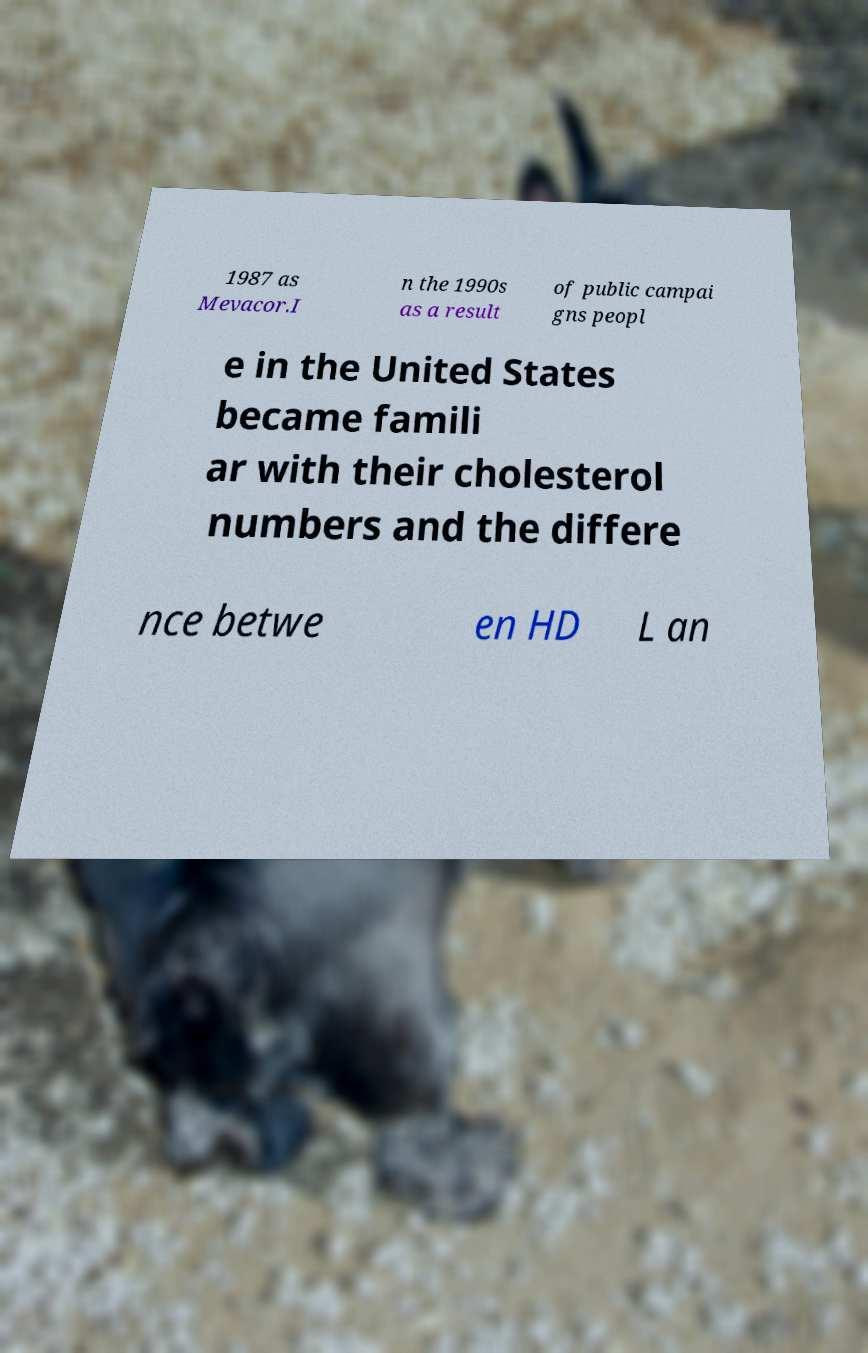Can you accurately transcribe the text from the provided image for me? 1987 as Mevacor.I n the 1990s as a result of public campai gns peopl e in the United States became famili ar with their cholesterol numbers and the differe nce betwe en HD L an 